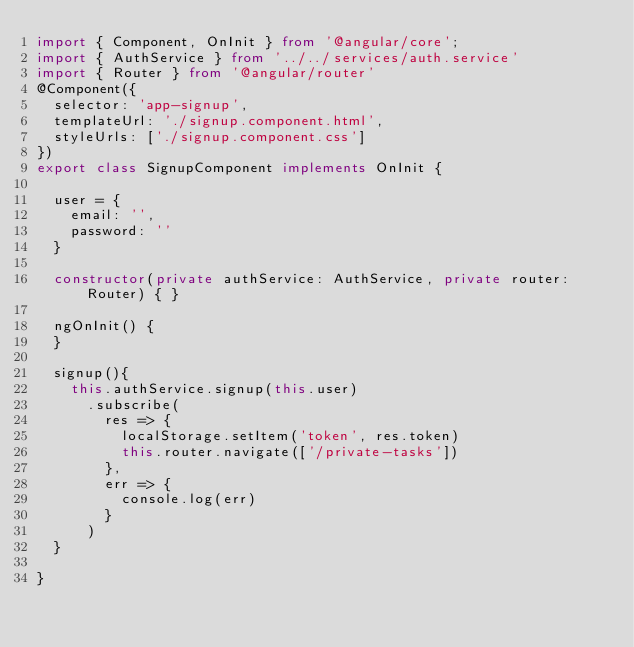<code> <loc_0><loc_0><loc_500><loc_500><_TypeScript_>import { Component, OnInit } from '@angular/core';
import { AuthService } from '../../services/auth.service'
import { Router } from '@angular/router'
@Component({
  selector: 'app-signup',
  templateUrl: './signup.component.html',
  styleUrls: ['./signup.component.css']
})
export class SignupComponent implements OnInit {

  user = {
    email: '',
    password: ''
  }

  constructor(private authService: AuthService, private router: Router) { }

  ngOnInit() {
  }

  signup(){
    this.authService.signup(this.user)
      .subscribe(
        res => {
          localStorage.setItem('token', res.token)
          this.router.navigate(['/private-tasks'])
        },
        err => {
          console.log(err)
        }
      )
  }

}
</code> 